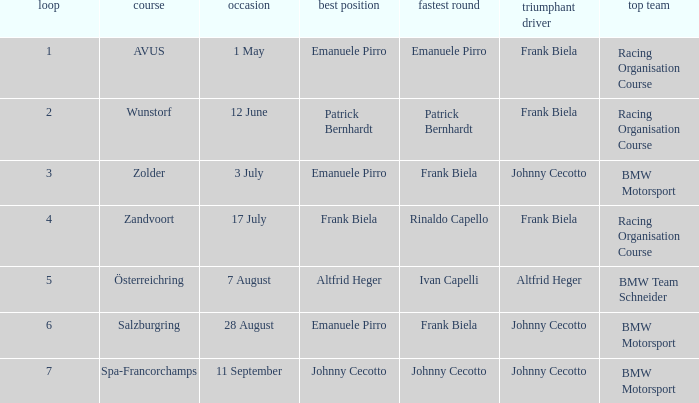Who was the winning team on the circuit Zolder? BMW Motorsport. 